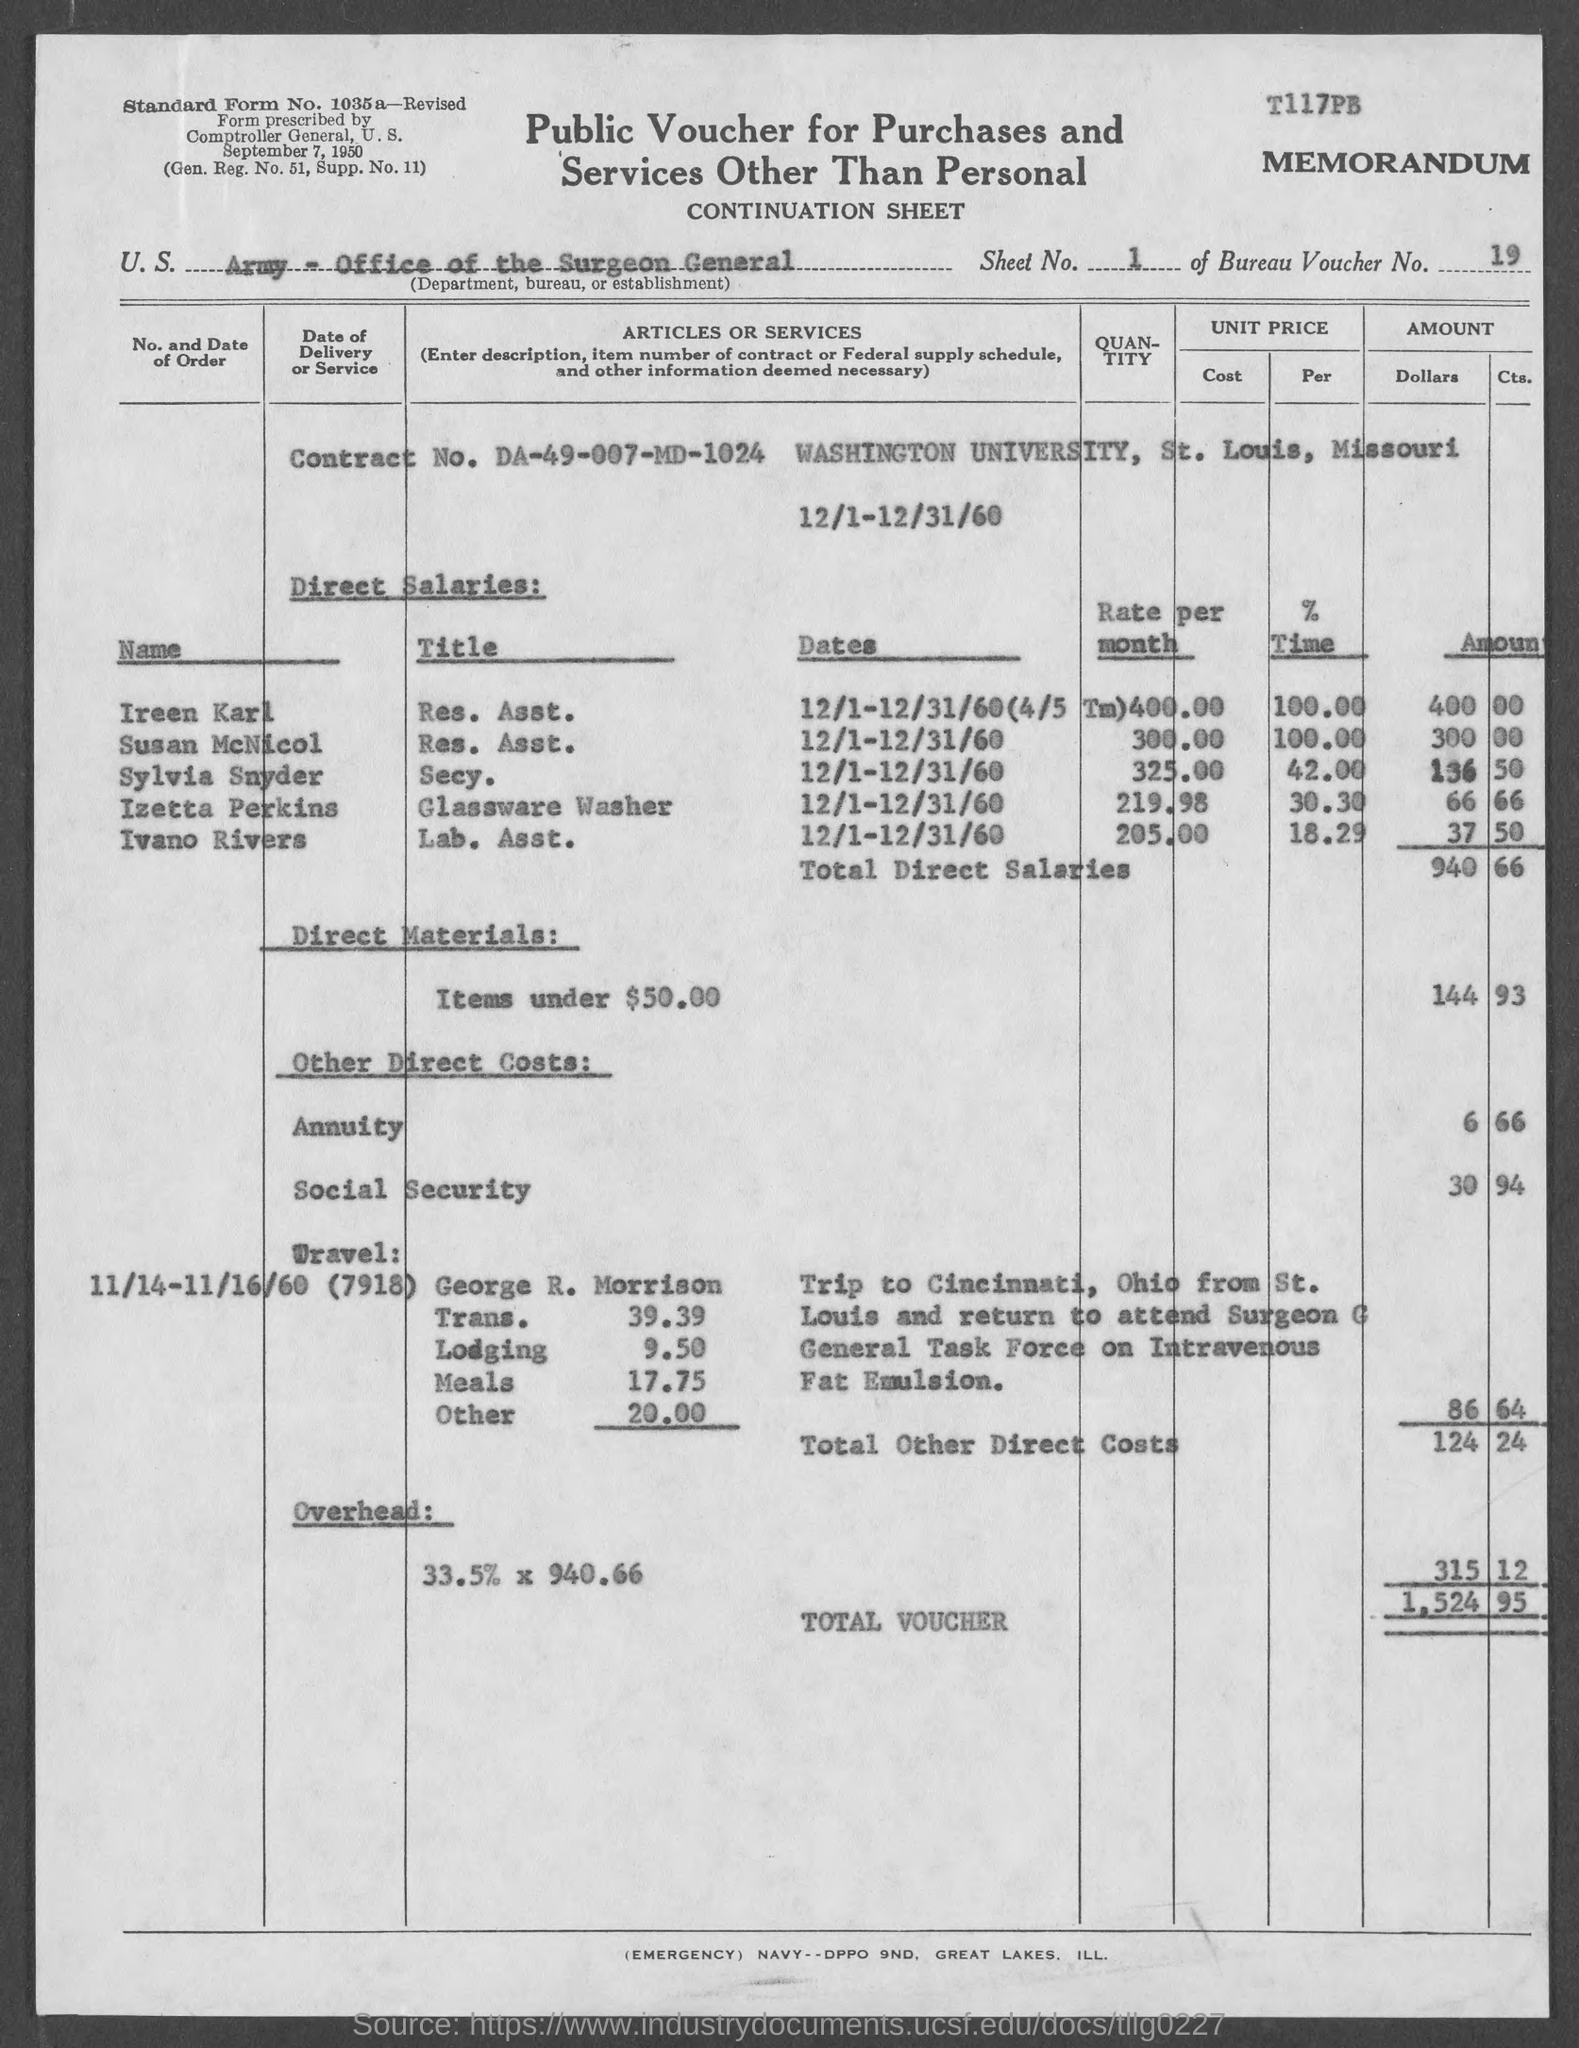What is the sheet no.?
Make the answer very short. 1. What is the bureau voucher no.?
Give a very brief answer. 19. What is the contract no.?
Offer a very short reply. DA-49-007-MD-1024. In which state is washington university at?
Ensure brevity in your answer.  Missouri. What is the total voucher amount ?
Your answer should be compact. 1,524 95. What is the title of ireen karl ?
Your answer should be compact. Res. Asst. What is the title of susan mcnicol ?
Keep it short and to the point. Res. Asst. What is the title of sylvia snyder ?
Keep it short and to the point. Secy. What is the title of izetta perkins ?
Your answer should be very brief. Glassware washer. What is the title of ivano rivers ?
Your answer should be very brief. Lab. Asst. 